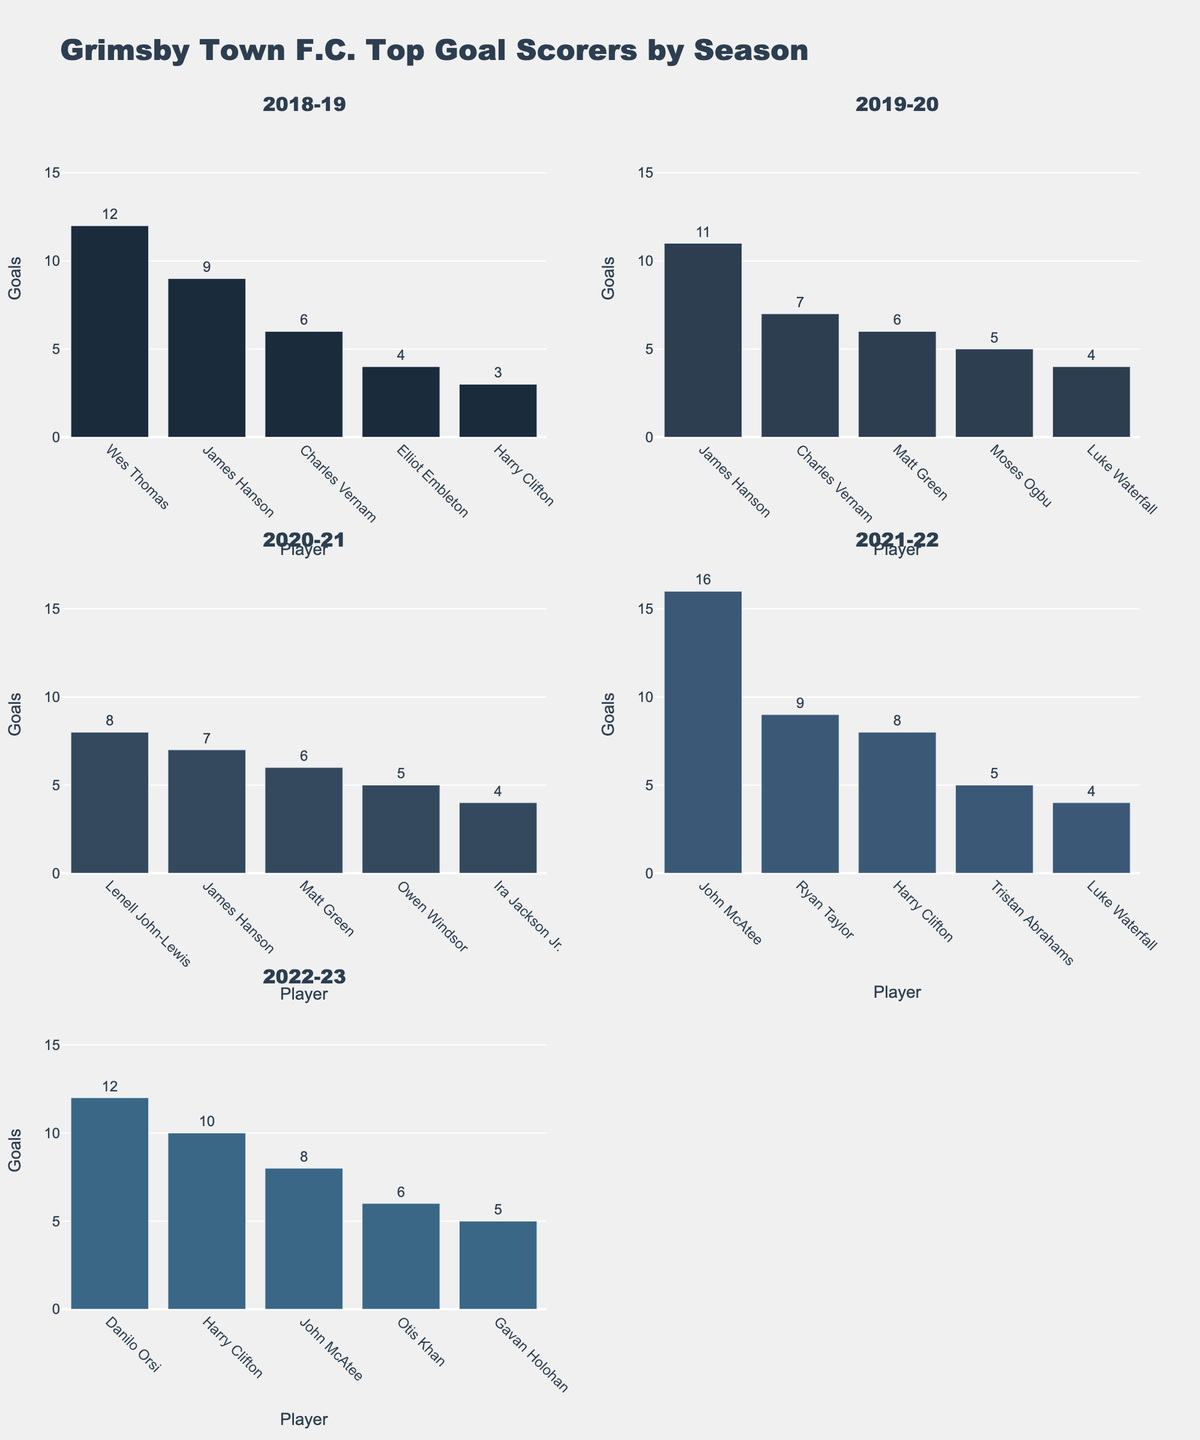What is the title of the subplot figure? The title is the text displayed at the top of the entire figure, usually provides a summary of what the figure is about. The title here is likely found above all the subplots.
Answer: Grimsby Town F.C. Top Goal Scorers by Season Which season had the player with the highest number of goals in a single season? To answer this, compare the highest bar in each subplot. John McAtee in the 2021-22 season has the highest bar with 16 goals.
Answer: 2021-22 Who scored the most goals in the 2020-21 season? Look at the 2020-21 subplot and find the player with the tallest bar. Lenell John-Lewis scored the most with 8 goals.
Answer: Lenell John-Lewis In which seasons did Harry Clifton appear as a top goal scorer? Look through each subplot to see in which seasons Harry Clifton appears as a scorer. He appears in 2018-19, 2021-22, and 2022-23.
Answer: 2018-19, 2021-22, 2022-23 What is James Hanson's total number of goals over all the seasons shown? Sum up James Hanson's goals in each season he appears: 9 in 2018-19, 11 in 2019-20, and 7 in 2020-21. The total is 27.
Answer: 27 Which season has the smallest range (difference) between the highest and lowest number of goals among the top scorers? Calculate the difference between the highest and lowest goals for each season. Compare these differences over all seasons. The smallest difference is in the 2020-21 season with 8 - 4 = 4.
Answer: 2020-21 Compare Danilo Orsi's goals in the 2022-23 season with John McAtee's goals in the 2021-22 season. Who scored more, and by how many goals? Danilo Orsi scored 12 goals in 2022-23, while John McAtee scored 16 goals in 2021-22. The difference is 16 - 12 = 4 goals, so John McAtee scored more.
Answer: John McAtee scored 4 more What is the average number of goals scored by the top 5 players in the 2019-20 season? Sum the goals of the top 5 players in the 2019-20 season (11+7+6+5+4 = 33) and divide by the number of players (5). The average is 33/5 = 6.6.
Answer: 6.6 Which player scored more goals in the 2022-23 season, Harry Clifton or Otis Khan? Look at the 2022-23 subplot and compare the heights of the bars for Harry Clifton and Otis Khan. Harry Clifton scored 10 goals, and Otis Khan scored 6 goals.
Answer: Harry Clifton How many seasons did Luke Waterfall appear as a top scorer? Count the number of subplots in which Luke Waterfall's name appears. He appears in the 2019-20 and 2021-22 seasons, so that's 2 seasons.
Answer: 2 